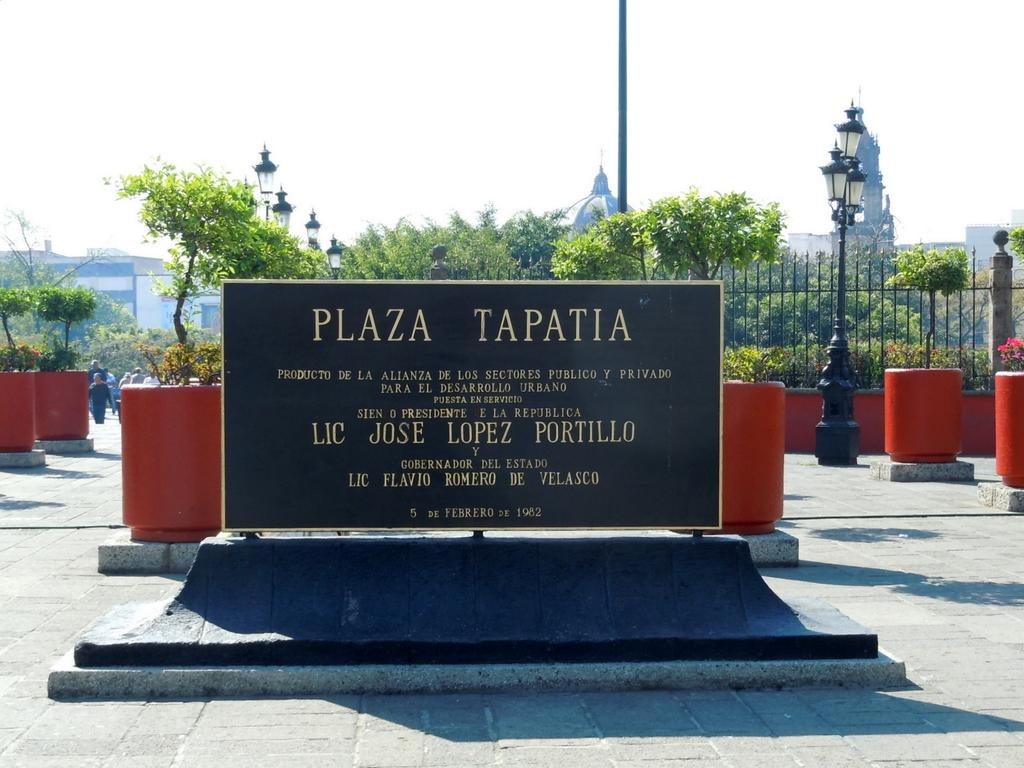What is the main subject in the middle of the image? There is a sculpture in the middle of the image. What type of natural vegetation can be seen in the image? There are trees visible in the image. What is visible at the top of the image? The sky is visible at the top of the image. What type of texture can be seen on the chin of the sculpture in the image? There is no chin present on the sculpture in the image, as it is not a human or animal figure. 